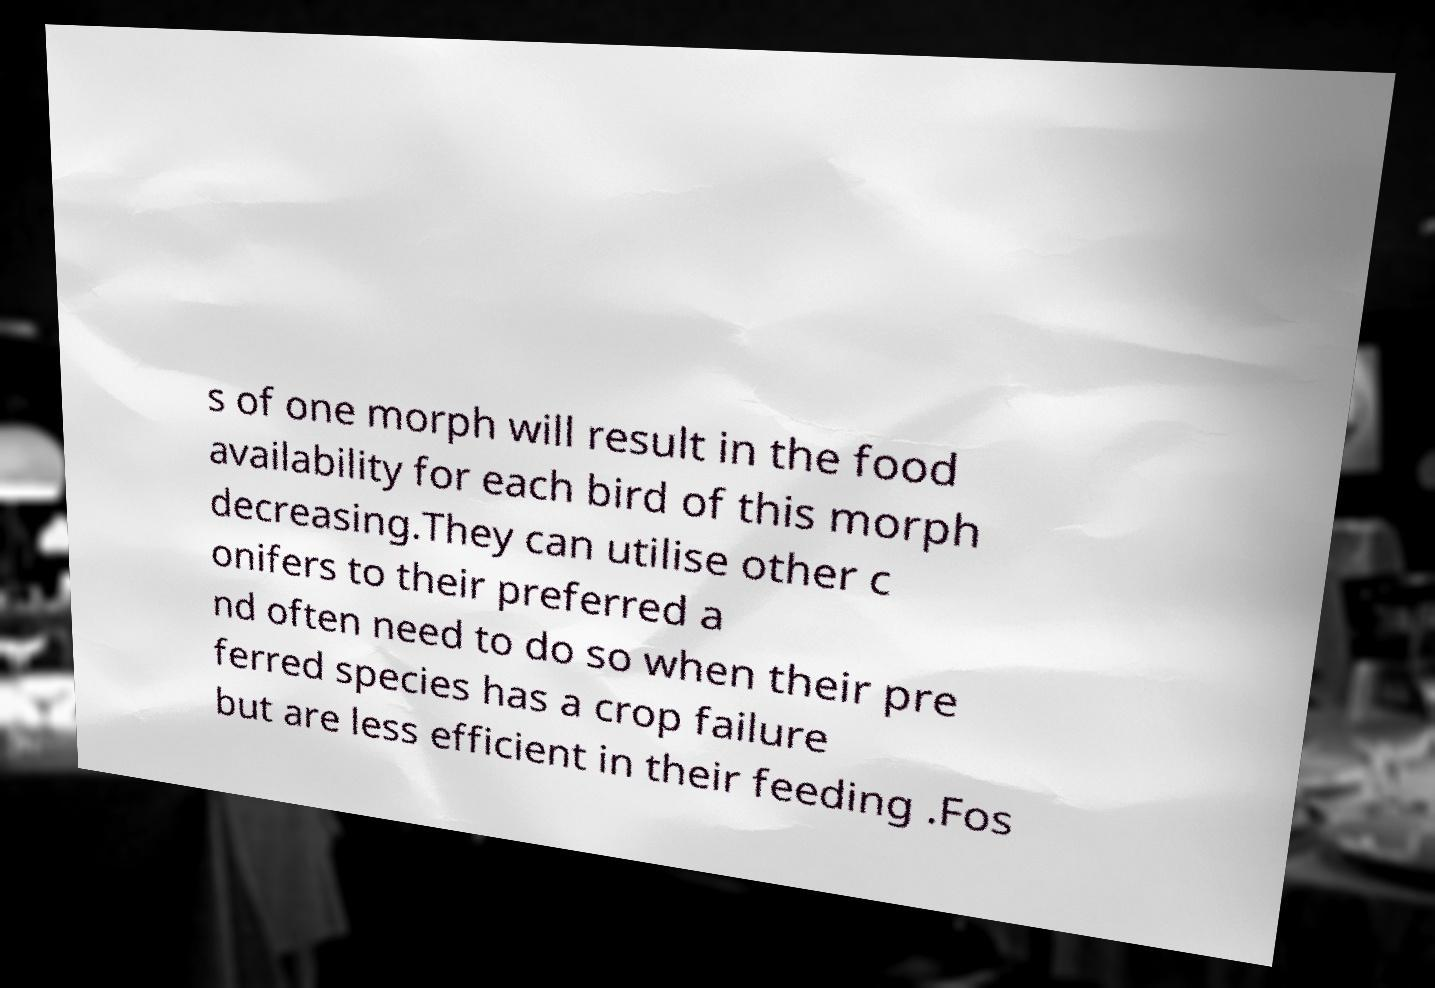There's text embedded in this image that I need extracted. Can you transcribe it verbatim? s of one morph will result in the food availability for each bird of this morph decreasing.They can utilise other c onifers to their preferred a nd often need to do so when their pre ferred species has a crop failure but are less efficient in their feeding .Fos 